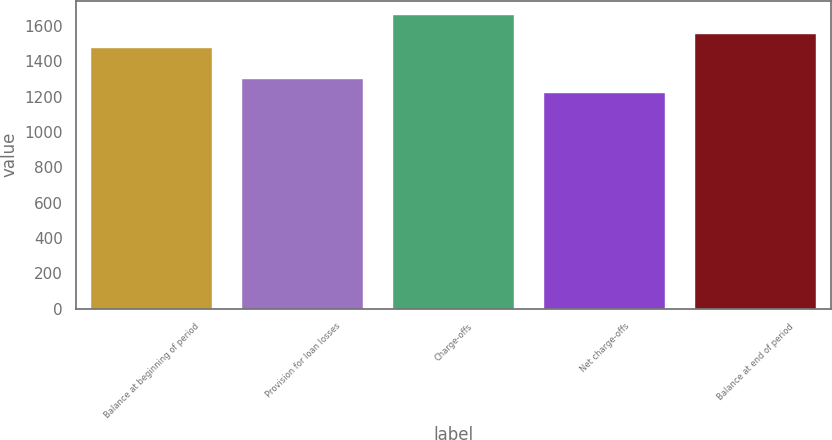<chart> <loc_0><loc_0><loc_500><loc_500><bar_chart><fcel>Balance at beginning of period<fcel>Provision for loan losses<fcel>Charge-offs<fcel>Net charge-offs<fcel>Balance at end of period<nl><fcel>1474<fcel>1300<fcel>1660<fcel>1220<fcel>1554<nl></chart> 